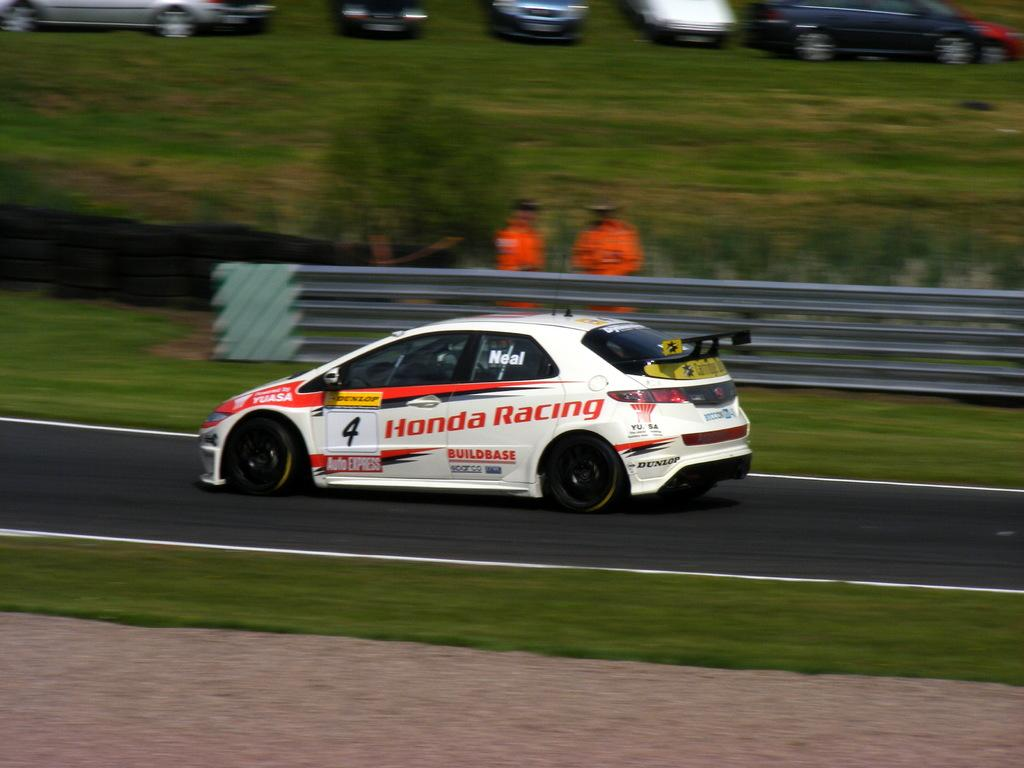Provide a one-sentence caption for the provided image. A white racing car on a track with Honda Racing and 4 on the side. 